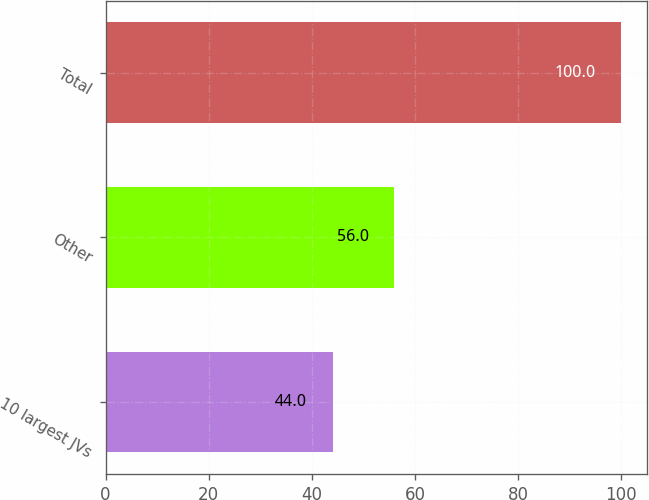Convert chart. <chart><loc_0><loc_0><loc_500><loc_500><bar_chart><fcel>10 largest JVs<fcel>Other<fcel>Total<nl><fcel>44<fcel>56<fcel>100<nl></chart> 